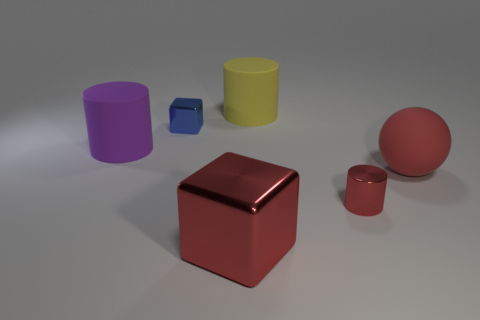Subtract all yellow cylinders. How many cylinders are left? 2 Subtract all rubber cylinders. How many cylinders are left? 1 Add 3 blue cubes. How many objects exist? 9 Subtract all blocks. How many objects are left? 4 Subtract 1 spheres. How many spheres are left? 0 Subtract all red blocks. Subtract all cyan cylinders. How many blocks are left? 1 Subtract all gray balls. How many blue cylinders are left? 0 Subtract all big red metallic objects. Subtract all large rubber cylinders. How many objects are left? 3 Add 5 large cubes. How many large cubes are left? 6 Add 6 large blocks. How many large blocks exist? 7 